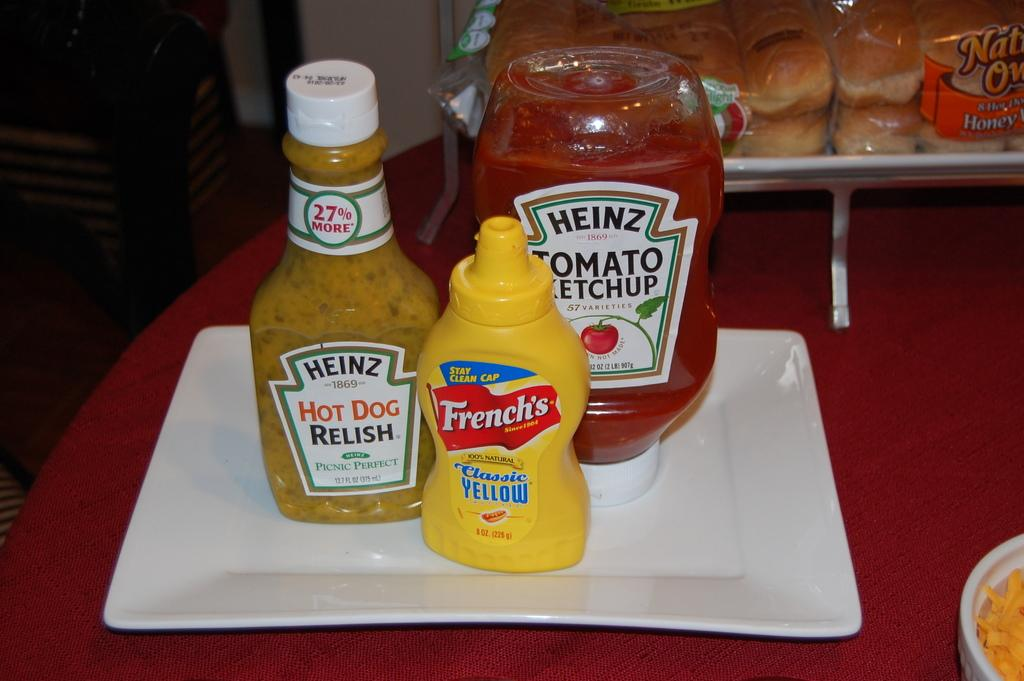<image>
Create a compact narrative representing the image presented. Bottles of Heinz relish and ketchup with a bottle of French's classic yellow mustard are on a plate. 